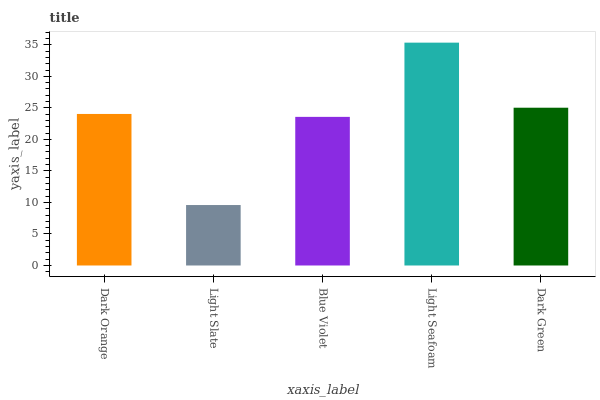Is Light Slate the minimum?
Answer yes or no. Yes. Is Light Seafoam the maximum?
Answer yes or no. Yes. Is Blue Violet the minimum?
Answer yes or no. No. Is Blue Violet the maximum?
Answer yes or no. No. Is Blue Violet greater than Light Slate?
Answer yes or no. Yes. Is Light Slate less than Blue Violet?
Answer yes or no. Yes. Is Light Slate greater than Blue Violet?
Answer yes or no. No. Is Blue Violet less than Light Slate?
Answer yes or no. No. Is Dark Orange the high median?
Answer yes or no. Yes. Is Dark Orange the low median?
Answer yes or no. Yes. Is Blue Violet the high median?
Answer yes or no. No. Is Blue Violet the low median?
Answer yes or no. No. 